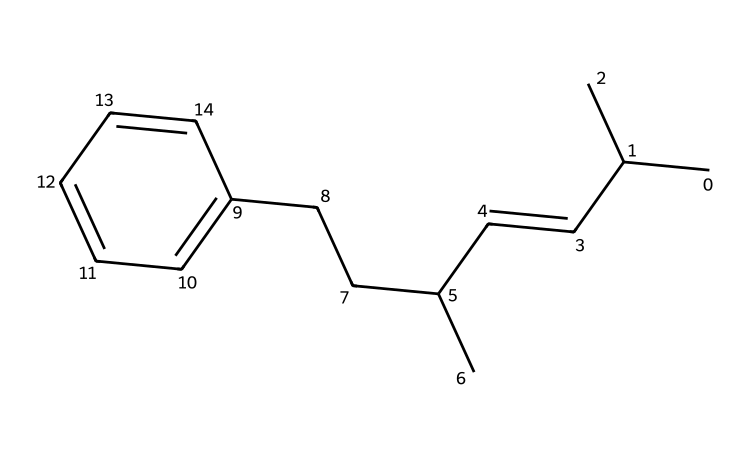What is the core structure of this polymer? The core structure of this polymer can be identified as a branched hydrocarbon backbone due to the presence of multiple carbon chains and branching points in the SMILES representation.
Answer: branched hydrocarbon How many carbon atoms are present in this polymer? By analyzing the SMILES representation, every carbon (C) notation represents a carbon atom, and counting all the distinct carbon atoms yields a total of 15.
Answer: 15 What type of polymer does this represent? This chemical structure represents a synthetic rubber polymer, often used in footwear because of its elasticity and durability, specifically in basketball shoe soles.
Answer: synthetic rubber What is the significance of the aromatic ring in this structure? The aromatic ring results in increased structural stability and contributes to the overall mechanical properties of the polymer, making it suitable for high-performance applications like sports shoes.
Answer: stability Which functional group is likely present in this polymer? The molecule predominantly consists of carbon and hydrogens with no functional groups evident in the SMILES representation, indicating it behaves like a hydrocarbon.
Answer: hydrocarbon What feature in the structure contributes to its flexibility? The presence of multiple branching points and double bonds within the hydrocarbon structure allows for a flexible and elastic material, which is crucial for rubber properties.
Answer: branching points 